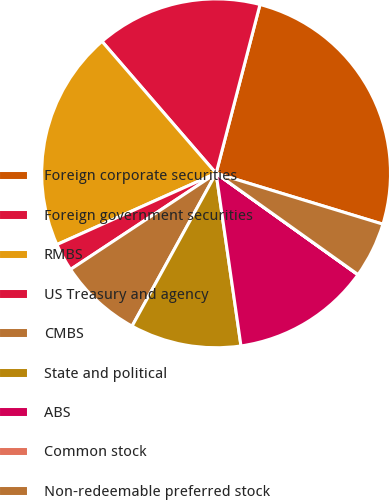Convert chart. <chart><loc_0><loc_0><loc_500><loc_500><pie_chart><fcel>Foreign corporate securities<fcel>Foreign government securities<fcel>RMBS<fcel>US Treasury and agency<fcel>CMBS<fcel>State and political<fcel>ABS<fcel>Common stock<fcel>Non-redeemable preferred stock<nl><fcel>25.66%<fcel>15.4%<fcel>20.35%<fcel>2.59%<fcel>7.71%<fcel>10.28%<fcel>12.84%<fcel>0.02%<fcel>5.15%<nl></chart> 